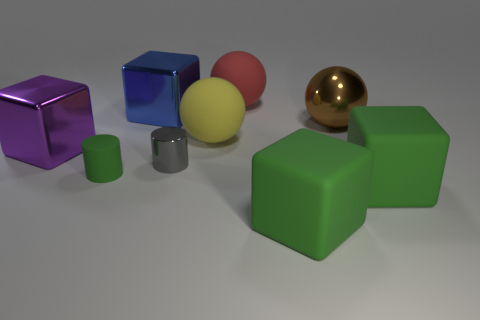Subtract all purple spheres. How many green blocks are left? 2 Subtract all large blue cubes. How many cubes are left? 3 Subtract 2 balls. How many balls are left? 1 Subtract all purple blocks. How many blocks are left? 3 Add 1 small matte objects. How many objects exist? 10 Subtract all yellow blocks. Subtract all green cylinders. How many blocks are left? 4 Subtract all cylinders. How many objects are left? 7 Subtract 1 gray cylinders. How many objects are left? 8 Subtract all blue balls. Subtract all small green objects. How many objects are left? 8 Add 3 purple objects. How many purple objects are left? 4 